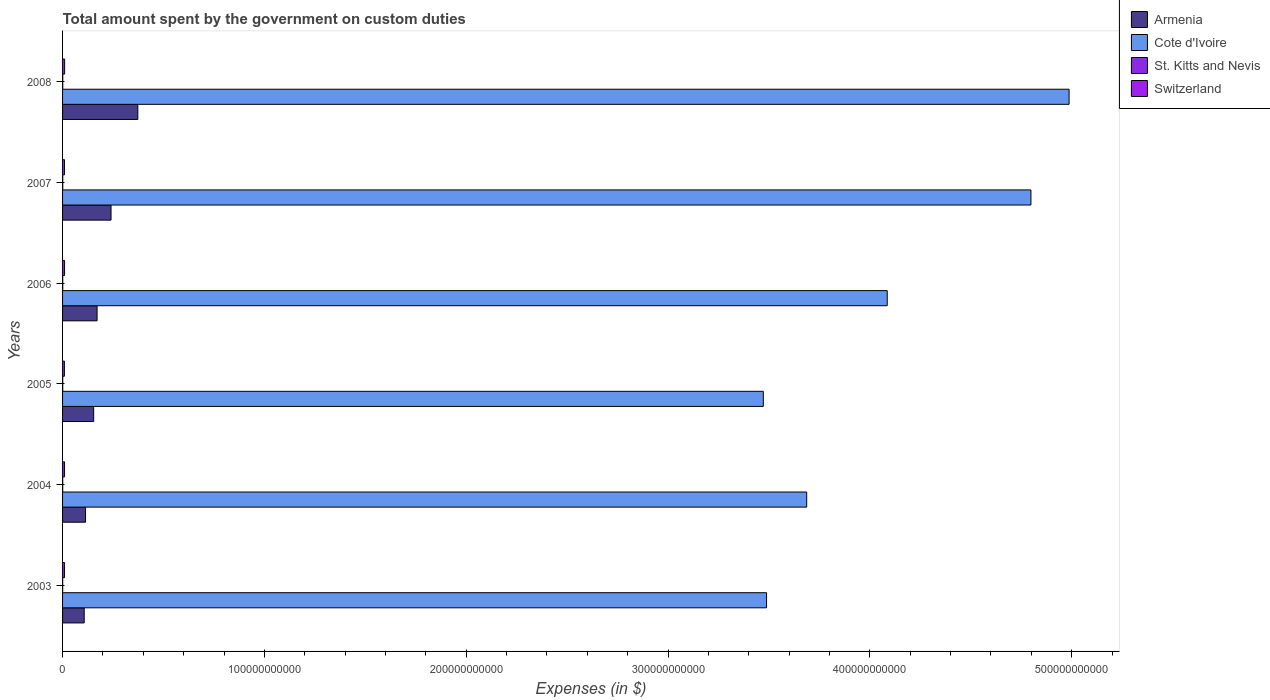How many different coloured bars are there?
Offer a terse response. 4. How many bars are there on the 3rd tick from the top?
Offer a very short reply. 4. How many bars are there on the 6th tick from the bottom?
Your answer should be compact. 4. In how many cases, is the number of bars for a given year not equal to the number of legend labels?
Offer a very short reply. 0. What is the amount spent on custom duties by the government in Cote d'Ivoire in 2006?
Keep it short and to the point. 4.09e+11. Across all years, what is the maximum amount spent on custom duties by the government in Switzerland?
Provide a succinct answer. 1.02e+09. Across all years, what is the minimum amount spent on custom duties by the government in Switzerland?
Your response must be concise. 9.09e+08. What is the total amount spent on custom duties by the government in Armenia in the graph?
Give a very brief answer. 1.16e+11. What is the difference between the amount spent on custom duties by the government in Switzerland in 2003 and that in 2008?
Your answer should be compact. -4.18e+07. What is the difference between the amount spent on custom duties by the government in Cote d'Ivoire in 2006 and the amount spent on custom duties by the government in Switzerland in 2008?
Ensure brevity in your answer.  4.08e+11. What is the average amount spent on custom duties by the government in Armenia per year?
Your answer should be compact. 1.93e+1. In the year 2008, what is the difference between the amount spent on custom duties by the government in Armenia and amount spent on custom duties by the government in Cote d'Ivoire?
Provide a succinct answer. -4.61e+11. In how many years, is the amount spent on custom duties by the government in Cote d'Ivoire greater than 240000000000 $?
Offer a very short reply. 6. What is the ratio of the amount spent on custom duties by the government in Switzerland in 2006 to that in 2007?
Your response must be concise. 1.03. Is the amount spent on custom duties by the government in St. Kitts and Nevis in 2004 less than that in 2007?
Give a very brief answer. Yes. What is the difference between the highest and the second highest amount spent on custom duties by the government in Armenia?
Provide a succinct answer. 1.33e+1. What is the difference between the highest and the lowest amount spent on custom duties by the government in St. Kitts and Nevis?
Ensure brevity in your answer.  3.56e+07. In how many years, is the amount spent on custom duties by the government in St. Kitts and Nevis greater than the average amount spent on custom duties by the government in St. Kitts and Nevis taken over all years?
Offer a terse response. 4. What does the 2nd bar from the top in 2007 represents?
Provide a short and direct response. St. Kitts and Nevis. What does the 3rd bar from the bottom in 2007 represents?
Your answer should be compact. St. Kitts and Nevis. What is the difference between two consecutive major ticks on the X-axis?
Ensure brevity in your answer.  1.00e+11. Where does the legend appear in the graph?
Keep it short and to the point. Top right. What is the title of the graph?
Ensure brevity in your answer.  Total amount spent by the government on custom duties. What is the label or title of the X-axis?
Your answer should be compact. Expenses (in $). What is the Expenses (in $) in Armenia in 2003?
Provide a short and direct response. 1.07e+1. What is the Expenses (in $) in Cote d'Ivoire in 2003?
Offer a very short reply. 3.49e+11. What is the Expenses (in $) of St. Kitts and Nevis in 2003?
Your answer should be very brief. 5.56e+07. What is the Expenses (in $) in Switzerland in 2003?
Give a very brief answer. 9.75e+08. What is the Expenses (in $) of Armenia in 2004?
Offer a terse response. 1.14e+1. What is the Expenses (in $) in Cote d'Ivoire in 2004?
Provide a short and direct response. 3.69e+11. What is the Expenses (in $) in St. Kitts and Nevis in 2004?
Offer a terse response. 6.50e+07. What is the Expenses (in $) of Switzerland in 2004?
Offer a terse response. 9.83e+08. What is the Expenses (in $) of Armenia in 2005?
Provide a short and direct response. 1.54e+1. What is the Expenses (in $) of Cote d'Ivoire in 2005?
Provide a succinct answer. 3.47e+11. What is the Expenses (in $) of St. Kitts and Nevis in 2005?
Offer a very short reply. 8.09e+07. What is the Expenses (in $) in Switzerland in 2005?
Ensure brevity in your answer.  9.09e+08. What is the Expenses (in $) of Armenia in 2006?
Provide a short and direct response. 1.71e+1. What is the Expenses (in $) of Cote d'Ivoire in 2006?
Your answer should be very brief. 4.09e+11. What is the Expenses (in $) of St. Kitts and Nevis in 2006?
Your response must be concise. 8.36e+07. What is the Expenses (in $) in Switzerland in 2006?
Your answer should be very brief. 9.86e+08. What is the Expenses (in $) in Armenia in 2007?
Make the answer very short. 2.40e+1. What is the Expenses (in $) in Cote d'Ivoire in 2007?
Offer a terse response. 4.80e+11. What is the Expenses (in $) of St. Kitts and Nevis in 2007?
Your response must be concise. 8.84e+07. What is the Expenses (in $) of Switzerland in 2007?
Provide a succinct answer. 9.61e+08. What is the Expenses (in $) in Armenia in 2008?
Your answer should be very brief. 3.73e+1. What is the Expenses (in $) of Cote d'Ivoire in 2008?
Offer a terse response. 4.99e+11. What is the Expenses (in $) in St. Kitts and Nevis in 2008?
Provide a short and direct response. 9.12e+07. What is the Expenses (in $) in Switzerland in 2008?
Your answer should be compact. 1.02e+09. Across all years, what is the maximum Expenses (in $) in Armenia?
Give a very brief answer. 3.73e+1. Across all years, what is the maximum Expenses (in $) in Cote d'Ivoire?
Provide a short and direct response. 4.99e+11. Across all years, what is the maximum Expenses (in $) of St. Kitts and Nevis?
Your response must be concise. 9.12e+07. Across all years, what is the maximum Expenses (in $) in Switzerland?
Give a very brief answer. 1.02e+09. Across all years, what is the minimum Expenses (in $) in Armenia?
Your answer should be compact. 1.07e+1. Across all years, what is the minimum Expenses (in $) in Cote d'Ivoire?
Your response must be concise. 3.47e+11. Across all years, what is the minimum Expenses (in $) in St. Kitts and Nevis?
Provide a succinct answer. 5.56e+07. Across all years, what is the minimum Expenses (in $) in Switzerland?
Give a very brief answer. 9.09e+08. What is the total Expenses (in $) in Armenia in the graph?
Your response must be concise. 1.16e+11. What is the total Expenses (in $) of Cote d'Ivoire in the graph?
Make the answer very short. 2.45e+12. What is the total Expenses (in $) of St. Kitts and Nevis in the graph?
Offer a terse response. 4.65e+08. What is the total Expenses (in $) of Switzerland in the graph?
Keep it short and to the point. 5.83e+09. What is the difference between the Expenses (in $) of Armenia in 2003 and that in 2004?
Give a very brief answer. -6.66e+08. What is the difference between the Expenses (in $) in Cote d'Ivoire in 2003 and that in 2004?
Ensure brevity in your answer.  -1.99e+1. What is the difference between the Expenses (in $) of St. Kitts and Nevis in 2003 and that in 2004?
Offer a terse response. -9.40e+06. What is the difference between the Expenses (in $) of Switzerland in 2003 and that in 2004?
Your answer should be compact. -8.05e+06. What is the difference between the Expenses (in $) in Armenia in 2003 and that in 2005?
Keep it short and to the point. -4.69e+09. What is the difference between the Expenses (in $) in Cote d'Ivoire in 2003 and that in 2005?
Your answer should be compact. 1.60e+09. What is the difference between the Expenses (in $) of St. Kitts and Nevis in 2003 and that in 2005?
Ensure brevity in your answer.  -2.53e+07. What is the difference between the Expenses (in $) in Switzerland in 2003 and that in 2005?
Ensure brevity in your answer.  6.64e+07. What is the difference between the Expenses (in $) of Armenia in 2003 and that in 2006?
Offer a terse response. -6.38e+09. What is the difference between the Expenses (in $) in Cote d'Ivoire in 2003 and that in 2006?
Keep it short and to the point. -5.98e+1. What is the difference between the Expenses (in $) in St. Kitts and Nevis in 2003 and that in 2006?
Ensure brevity in your answer.  -2.80e+07. What is the difference between the Expenses (in $) in Switzerland in 2003 and that in 2006?
Your response must be concise. -1.11e+07. What is the difference between the Expenses (in $) of Armenia in 2003 and that in 2007?
Give a very brief answer. -1.33e+1. What is the difference between the Expenses (in $) in Cote d'Ivoire in 2003 and that in 2007?
Your answer should be compact. -1.31e+11. What is the difference between the Expenses (in $) of St. Kitts and Nevis in 2003 and that in 2007?
Provide a short and direct response. -3.28e+07. What is the difference between the Expenses (in $) in Switzerland in 2003 and that in 2007?
Provide a succinct answer. 1.48e+07. What is the difference between the Expenses (in $) of Armenia in 2003 and that in 2008?
Your answer should be very brief. -2.66e+1. What is the difference between the Expenses (in $) in Cote d'Ivoire in 2003 and that in 2008?
Provide a succinct answer. -1.50e+11. What is the difference between the Expenses (in $) in St. Kitts and Nevis in 2003 and that in 2008?
Offer a terse response. -3.56e+07. What is the difference between the Expenses (in $) in Switzerland in 2003 and that in 2008?
Your answer should be very brief. -4.18e+07. What is the difference between the Expenses (in $) of Armenia in 2004 and that in 2005?
Your answer should be very brief. -4.02e+09. What is the difference between the Expenses (in $) in Cote d'Ivoire in 2004 and that in 2005?
Your answer should be compact. 2.15e+1. What is the difference between the Expenses (in $) in St. Kitts and Nevis in 2004 and that in 2005?
Ensure brevity in your answer.  -1.59e+07. What is the difference between the Expenses (in $) in Switzerland in 2004 and that in 2005?
Your answer should be very brief. 7.45e+07. What is the difference between the Expenses (in $) of Armenia in 2004 and that in 2006?
Your answer should be compact. -5.71e+09. What is the difference between the Expenses (in $) in Cote d'Ivoire in 2004 and that in 2006?
Your answer should be very brief. -3.99e+1. What is the difference between the Expenses (in $) of St. Kitts and Nevis in 2004 and that in 2006?
Ensure brevity in your answer.  -1.86e+07. What is the difference between the Expenses (in $) in Switzerland in 2004 and that in 2006?
Your answer should be very brief. -3.08e+06. What is the difference between the Expenses (in $) of Armenia in 2004 and that in 2007?
Your answer should be compact. -1.26e+1. What is the difference between the Expenses (in $) of Cote d'Ivoire in 2004 and that in 2007?
Your answer should be very brief. -1.11e+11. What is the difference between the Expenses (in $) in St. Kitts and Nevis in 2004 and that in 2007?
Your answer should be compact. -2.34e+07. What is the difference between the Expenses (in $) in Switzerland in 2004 and that in 2007?
Provide a short and direct response. 2.28e+07. What is the difference between the Expenses (in $) in Armenia in 2004 and that in 2008?
Offer a terse response. -2.59e+1. What is the difference between the Expenses (in $) of Cote d'Ivoire in 2004 and that in 2008?
Your response must be concise. -1.30e+11. What is the difference between the Expenses (in $) of St. Kitts and Nevis in 2004 and that in 2008?
Keep it short and to the point. -2.62e+07. What is the difference between the Expenses (in $) in Switzerland in 2004 and that in 2008?
Offer a terse response. -3.38e+07. What is the difference between the Expenses (in $) in Armenia in 2005 and that in 2006?
Provide a succinct answer. -1.69e+09. What is the difference between the Expenses (in $) of Cote d'Ivoire in 2005 and that in 2006?
Keep it short and to the point. -6.14e+1. What is the difference between the Expenses (in $) in St. Kitts and Nevis in 2005 and that in 2006?
Give a very brief answer. -2.70e+06. What is the difference between the Expenses (in $) in Switzerland in 2005 and that in 2006?
Provide a short and direct response. -7.76e+07. What is the difference between the Expenses (in $) in Armenia in 2005 and that in 2007?
Your answer should be compact. -8.60e+09. What is the difference between the Expenses (in $) in Cote d'Ivoire in 2005 and that in 2007?
Offer a very short reply. -1.33e+11. What is the difference between the Expenses (in $) of St. Kitts and Nevis in 2005 and that in 2007?
Make the answer very short. -7.50e+06. What is the difference between the Expenses (in $) in Switzerland in 2005 and that in 2007?
Your response must be concise. -5.17e+07. What is the difference between the Expenses (in $) in Armenia in 2005 and that in 2008?
Offer a terse response. -2.19e+1. What is the difference between the Expenses (in $) in Cote d'Ivoire in 2005 and that in 2008?
Keep it short and to the point. -1.52e+11. What is the difference between the Expenses (in $) of St. Kitts and Nevis in 2005 and that in 2008?
Make the answer very short. -1.03e+07. What is the difference between the Expenses (in $) of Switzerland in 2005 and that in 2008?
Your response must be concise. -1.08e+08. What is the difference between the Expenses (in $) in Armenia in 2006 and that in 2007?
Your response must be concise. -6.91e+09. What is the difference between the Expenses (in $) in Cote d'Ivoire in 2006 and that in 2007?
Offer a very short reply. -7.12e+1. What is the difference between the Expenses (in $) in St. Kitts and Nevis in 2006 and that in 2007?
Offer a terse response. -4.80e+06. What is the difference between the Expenses (in $) of Switzerland in 2006 and that in 2007?
Make the answer very short. 2.59e+07. What is the difference between the Expenses (in $) of Armenia in 2006 and that in 2008?
Give a very brief answer. -2.02e+1. What is the difference between the Expenses (in $) of Cote d'Ivoire in 2006 and that in 2008?
Offer a terse response. -9.01e+1. What is the difference between the Expenses (in $) of St. Kitts and Nevis in 2006 and that in 2008?
Provide a short and direct response. -7.60e+06. What is the difference between the Expenses (in $) in Switzerland in 2006 and that in 2008?
Offer a very short reply. -3.07e+07. What is the difference between the Expenses (in $) in Armenia in 2007 and that in 2008?
Your answer should be compact. -1.33e+1. What is the difference between the Expenses (in $) of Cote d'Ivoire in 2007 and that in 2008?
Give a very brief answer. -1.89e+1. What is the difference between the Expenses (in $) in St. Kitts and Nevis in 2007 and that in 2008?
Ensure brevity in your answer.  -2.80e+06. What is the difference between the Expenses (in $) of Switzerland in 2007 and that in 2008?
Make the answer very short. -5.66e+07. What is the difference between the Expenses (in $) in Armenia in 2003 and the Expenses (in $) in Cote d'Ivoire in 2004?
Give a very brief answer. -3.58e+11. What is the difference between the Expenses (in $) in Armenia in 2003 and the Expenses (in $) in St. Kitts and Nevis in 2004?
Offer a very short reply. 1.07e+1. What is the difference between the Expenses (in $) in Armenia in 2003 and the Expenses (in $) in Switzerland in 2004?
Give a very brief answer. 9.74e+09. What is the difference between the Expenses (in $) of Cote d'Ivoire in 2003 and the Expenses (in $) of St. Kitts and Nevis in 2004?
Provide a succinct answer. 3.49e+11. What is the difference between the Expenses (in $) in Cote d'Ivoire in 2003 and the Expenses (in $) in Switzerland in 2004?
Offer a very short reply. 3.48e+11. What is the difference between the Expenses (in $) of St. Kitts and Nevis in 2003 and the Expenses (in $) of Switzerland in 2004?
Give a very brief answer. -9.28e+08. What is the difference between the Expenses (in $) of Armenia in 2003 and the Expenses (in $) of Cote d'Ivoire in 2005?
Give a very brief answer. -3.36e+11. What is the difference between the Expenses (in $) in Armenia in 2003 and the Expenses (in $) in St. Kitts and Nevis in 2005?
Give a very brief answer. 1.06e+1. What is the difference between the Expenses (in $) in Armenia in 2003 and the Expenses (in $) in Switzerland in 2005?
Provide a succinct answer. 9.82e+09. What is the difference between the Expenses (in $) of Cote d'Ivoire in 2003 and the Expenses (in $) of St. Kitts and Nevis in 2005?
Your answer should be compact. 3.49e+11. What is the difference between the Expenses (in $) of Cote d'Ivoire in 2003 and the Expenses (in $) of Switzerland in 2005?
Make the answer very short. 3.48e+11. What is the difference between the Expenses (in $) in St. Kitts and Nevis in 2003 and the Expenses (in $) in Switzerland in 2005?
Ensure brevity in your answer.  -8.53e+08. What is the difference between the Expenses (in $) of Armenia in 2003 and the Expenses (in $) of Cote d'Ivoire in 2006?
Offer a very short reply. -3.98e+11. What is the difference between the Expenses (in $) of Armenia in 2003 and the Expenses (in $) of St. Kitts and Nevis in 2006?
Ensure brevity in your answer.  1.06e+1. What is the difference between the Expenses (in $) of Armenia in 2003 and the Expenses (in $) of Switzerland in 2006?
Offer a very short reply. 9.74e+09. What is the difference between the Expenses (in $) of Cote d'Ivoire in 2003 and the Expenses (in $) of St. Kitts and Nevis in 2006?
Offer a terse response. 3.49e+11. What is the difference between the Expenses (in $) in Cote d'Ivoire in 2003 and the Expenses (in $) in Switzerland in 2006?
Keep it short and to the point. 3.48e+11. What is the difference between the Expenses (in $) in St. Kitts and Nevis in 2003 and the Expenses (in $) in Switzerland in 2006?
Your answer should be compact. -9.31e+08. What is the difference between the Expenses (in $) of Armenia in 2003 and the Expenses (in $) of Cote d'Ivoire in 2007?
Provide a succinct answer. -4.69e+11. What is the difference between the Expenses (in $) in Armenia in 2003 and the Expenses (in $) in St. Kitts and Nevis in 2007?
Give a very brief answer. 1.06e+1. What is the difference between the Expenses (in $) in Armenia in 2003 and the Expenses (in $) in Switzerland in 2007?
Ensure brevity in your answer.  9.76e+09. What is the difference between the Expenses (in $) in Cote d'Ivoire in 2003 and the Expenses (in $) in St. Kitts and Nevis in 2007?
Your answer should be compact. 3.49e+11. What is the difference between the Expenses (in $) in Cote d'Ivoire in 2003 and the Expenses (in $) in Switzerland in 2007?
Provide a succinct answer. 3.48e+11. What is the difference between the Expenses (in $) of St. Kitts and Nevis in 2003 and the Expenses (in $) of Switzerland in 2007?
Ensure brevity in your answer.  -9.05e+08. What is the difference between the Expenses (in $) in Armenia in 2003 and the Expenses (in $) in Cote d'Ivoire in 2008?
Offer a terse response. -4.88e+11. What is the difference between the Expenses (in $) of Armenia in 2003 and the Expenses (in $) of St. Kitts and Nevis in 2008?
Your answer should be very brief. 1.06e+1. What is the difference between the Expenses (in $) of Armenia in 2003 and the Expenses (in $) of Switzerland in 2008?
Offer a very short reply. 9.71e+09. What is the difference between the Expenses (in $) in Cote d'Ivoire in 2003 and the Expenses (in $) in St. Kitts and Nevis in 2008?
Your response must be concise. 3.49e+11. What is the difference between the Expenses (in $) of Cote d'Ivoire in 2003 and the Expenses (in $) of Switzerland in 2008?
Your response must be concise. 3.48e+11. What is the difference between the Expenses (in $) of St. Kitts and Nevis in 2003 and the Expenses (in $) of Switzerland in 2008?
Give a very brief answer. -9.61e+08. What is the difference between the Expenses (in $) in Armenia in 2004 and the Expenses (in $) in Cote d'Ivoire in 2005?
Provide a short and direct response. -3.36e+11. What is the difference between the Expenses (in $) in Armenia in 2004 and the Expenses (in $) in St. Kitts and Nevis in 2005?
Your answer should be very brief. 1.13e+1. What is the difference between the Expenses (in $) in Armenia in 2004 and the Expenses (in $) in Switzerland in 2005?
Keep it short and to the point. 1.05e+1. What is the difference between the Expenses (in $) in Cote d'Ivoire in 2004 and the Expenses (in $) in St. Kitts and Nevis in 2005?
Your response must be concise. 3.69e+11. What is the difference between the Expenses (in $) of Cote d'Ivoire in 2004 and the Expenses (in $) of Switzerland in 2005?
Your answer should be compact. 3.68e+11. What is the difference between the Expenses (in $) in St. Kitts and Nevis in 2004 and the Expenses (in $) in Switzerland in 2005?
Your response must be concise. -8.44e+08. What is the difference between the Expenses (in $) of Armenia in 2004 and the Expenses (in $) of Cote d'Ivoire in 2006?
Provide a short and direct response. -3.97e+11. What is the difference between the Expenses (in $) in Armenia in 2004 and the Expenses (in $) in St. Kitts and Nevis in 2006?
Your answer should be compact. 1.13e+1. What is the difference between the Expenses (in $) of Armenia in 2004 and the Expenses (in $) of Switzerland in 2006?
Keep it short and to the point. 1.04e+1. What is the difference between the Expenses (in $) in Cote d'Ivoire in 2004 and the Expenses (in $) in St. Kitts and Nevis in 2006?
Make the answer very short. 3.69e+11. What is the difference between the Expenses (in $) of Cote d'Ivoire in 2004 and the Expenses (in $) of Switzerland in 2006?
Provide a short and direct response. 3.68e+11. What is the difference between the Expenses (in $) in St. Kitts and Nevis in 2004 and the Expenses (in $) in Switzerland in 2006?
Make the answer very short. -9.21e+08. What is the difference between the Expenses (in $) in Armenia in 2004 and the Expenses (in $) in Cote d'Ivoire in 2007?
Provide a short and direct response. -4.68e+11. What is the difference between the Expenses (in $) of Armenia in 2004 and the Expenses (in $) of St. Kitts and Nevis in 2007?
Provide a succinct answer. 1.13e+1. What is the difference between the Expenses (in $) of Armenia in 2004 and the Expenses (in $) of Switzerland in 2007?
Your answer should be compact. 1.04e+1. What is the difference between the Expenses (in $) in Cote d'Ivoire in 2004 and the Expenses (in $) in St. Kitts and Nevis in 2007?
Your answer should be compact. 3.69e+11. What is the difference between the Expenses (in $) of Cote d'Ivoire in 2004 and the Expenses (in $) of Switzerland in 2007?
Ensure brevity in your answer.  3.68e+11. What is the difference between the Expenses (in $) of St. Kitts and Nevis in 2004 and the Expenses (in $) of Switzerland in 2007?
Keep it short and to the point. -8.96e+08. What is the difference between the Expenses (in $) in Armenia in 2004 and the Expenses (in $) in Cote d'Ivoire in 2008?
Your answer should be compact. -4.87e+11. What is the difference between the Expenses (in $) in Armenia in 2004 and the Expenses (in $) in St. Kitts and Nevis in 2008?
Your answer should be very brief. 1.13e+1. What is the difference between the Expenses (in $) of Armenia in 2004 and the Expenses (in $) of Switzerland in 2008?
Keep it short and to the point. 1.04e+1. What is the difference between the Expenses (in $) of Cote d'Ivoire in 2004 and the Expenses (in $) of St. Kitts and Nevis in 2008?
Provide a succinct answer. 3.69e+11. What is the difference between the Expenses (in $) in Cote d'Ivoire in 2004 and the Expenses (in $) in Switzerland in 2008?
Offer a very short reply. 3.68e+11. What is the difference between the Expenses (in $) in St. Kitts and Nevis in 2004 and the Expenses (in $) in Switzerland in 2008?
Ensure brevity in your answer.  -9.52e+08. What is the difference between the Expenses (in $) in Armenia in 2005 and the Expenses (in $) in Cote d'Ivoire in 2006?
Your answer should be very brief. -3.93e+11. What is the difference between the Expenses (in $) of Armenia in 2005 and the Expenses (in $) of St. Kitts and Nevis in 2006?
Keep it short and to the point. 1.53e+1. What is the difference between the Expenses (in $) in Armenia in 2005 and the Expenses (in $) in Switzerland in 2006?
Offer a very short reply. 1.44e+1. What is the difference between the Expenses (in $) in Cote d'Ivoire in 2005 and the Expenses (in $) in St. Kitts and Nevis in 2006?
Provide a succinct answer. 3.47e+11. What is the difference between the Expenses (in $) in Cote d'Ivoire in 2005 and the Expenses (in $) in Switzerland in 2006?
Make the answer very short. 3.46e+11. What is the difference between the Expenses (in $) in St. Kitts and Nevis in 2005 and the Expenses (in $) in Switzerland in 2006?
Provide a succinct answer. -9.06e+08. What is the difference between the Expenses (in $) in Armenia in 2005 and the Expenses (in $) in Cote d'Ivoire in 2007?
Your answer should be very brief. -4.64e+11. What is the difference between the Expenses (in $) in Armenia in 2005 and the Expenses (in $) in St. Kitts and Nevis in 2007?
Keep it short and to the point. 1.53e+1. What is the difference between the Expenses (in $) in Armenia in 2005 and the Expenses (in $) in Switzerland in 2007?
Offer a very short reply. 1.44e+1. What is the difference between the Expenses (in $) of Cote d'Ivoire in 2005 and the Expenses (in $) of St. Kitts and Nevis in 2007?
Give a very brief answer. 3.47e+11. What is the difference between the Expenses (in $) of Cote d'Ivoire in 2005 and the Expenses (in $) of Switzerland in 2007?
Offer a terse response. 3.46e+11. What is the difference between the Expenses (in $) in St. Kitts and Nevis in 2005 and the Expenses (in $) in Switzerland in 2007?
Ensure brevity in your answer.  -8.80e+08. What is the difference between the Expenses (in $) in Armenia in 2005 and the Expenses (in $) in Cote d'Ivoire in 2008?
Offer a very short reply. -4.83e+11. What is the difference between the Expenses (in $) of Armenia in 2005 and the Expenses (in $) of St. Kitts and Nevis in 2008?
Your response must be concise. 1.53e+1. What is the difference between the Expenses (in $) in Armenia in 2005 and the Expenses (in $) in Switzerland in 2008?
Your response must be concise. 1.44e+1. What is the difference between the Expenses (in $) of Cote d'Ivoire in 2005 and the Expenses (in $) of St. Kitts and Nevis in 2008?
Make the answer very short. 3.47e+11. What is the difference between the Expenses (in $) of Cote d'Ivoire in 2005 and the Expenses (in $) of Switzerland in 2008?
Your answer should be compact. 3.46e+11. What is the difference between the Expenses (in $) in St. Kitts and Nevis in 2005 and the Expenses (in $) in Switzerland in 2008?
Make the answer very short. -9.36e+08. What is the difference between the Expenses (in $) in Armenia in 2006 and the Expenses (in $) in Cote d'Ivoire in 2007?
Keep it short and to the point. -4.63e+11. What is the difference between the Expenses (in $) of Armenia in 2006 and the Expenses (in $) of St. Kitts and Nevis in 2007?
Provide a succinct answer. 1.70e+1. What is the difference between the Expenses (in $) in Armenia in 2006 and the Expenses (in $) in Switzerland in 2007?
Provide a short and direct response. 1.61e+1. What is the difference between the Expenses (in $) of Cote d'Ivoire in 2006 and the Expenses (in $) of St. Kitts and Nevis in 2007?
Your response must be concise. 4.09e+11. What is the difference between the Expenses (in $) of Cote d'Ivoire in 2006 and the Expenses (in $) of Switzerland in 2007?
Offer a terse response. 4.08e+11. What is the difference between the Expenses (in $) in St. Kitts and Nevis in 2006 and the Expenses (in $) in Switzerland in 2007?
Provide a succinct answer. -8.77e+08. What is the difference between the Expenses (in $) in Armenia in 2006 and the Expenses (in $) in Cote d'Ivoire in 2008?
Ensure brevity in your answer.  -4.82e+11. What is the difference between the Expenses (in $) of Armenia in 2006 and the Expenses (in $) of St. Kitts and Nevis in 2008?
Make the answer very short. 1.70e+1. What is the difference between the Expenses (in $) of Armenia in 2006 and the Expenses (in $) of Switzerland in 2008?
Your answer should be compact. 1.61e+1. What is the difference between the Expenses (in $) in Cote d'Ivoire in 2006 and the Expenses (in $) in St. Kitts and Nevis in 2008?
Your answer should be very brief. 4.09e+11. What is the difference between the Expenses (in $) of Cote d'Ivoire in 2006 and the Expenses (in $) of Switzerland in 2008?
Offer a very short reply. 4.08e+11. What is the difference between the Expenses (in $) of St. Kitts and Nevis in 2006 and the Expenses (in $) of Switzerland in 2008?
Offer a terse response. -9.33e+08. What is the difference between the Expenses (in $) of Armenia in 2007 and the Expenses (in $) of Cote d'Ivoire in 2008?
Offer a very short reply. -4.75e+11. What is the difference between the Expenses (in $) of Armenia in 2007 and the Expenses (in $) of St. Kitts and Nevis in 2008?
Your response must be concise. 2.39e+1. What is the difference between the Expenses (in $) in Armenia in 2007 and the Expenses (in $) in Switzerland in 2008?
Provide a succinct answer. 2.30e+1. What is the difference between the Expenses (in $) in Cote d'Ivoire in 2007 and the Expenses (in $) in St. Kitts and Nevis in 2008?
Your response must be concise. 4.80e+11. What is the difference between the Expenses (in $) of Cote d'Ivoire in 2007 and the Expenses (in $) of Switzerland in 2008?
Provide a succinct answer. 4.79e+11. What is the difference between the Expenses (in $) of St. Kitts and Nevis in 2007 and the Expenses (in $) of Switzerland in 2008?
Provide a short and direct response. -9.29e+08. What is the average Expenses (in $) in Armenia per year?
Your answer should be compact. 1.93e+1. What is the average Expenses (in $) of Cote d'Ivoire per year?
Make the answer very short. 4.09e+11. What is the average Expenses (in $) of St. Kitts and Nevis per year?
Ensure brevity in your answer.  7.74e+07. What is the average Expenses (in $) in Switzerland per year?
Offer a very short reply. 9.72e+08. In the year 2003, what is the difference between the Expenses (in $) of Armenia and Expenses (in $) of Cote d'Ivoire?
Your answer should be compact. -3.38e+11. In the year 2003, what is the difference between the Expenses (in $) in Armenia and Expenses (in $) in St. Kitts and Nevis?
Your response must be concise. 1.07e+1. In the year 2003, what is the difference between the Expenses (in $) of Armenia and Expenses (in $) of Switzerland?
Offer a very short reply. 9.75e+09. In the year 2003, what is the difference between the Expenses (in $) in Cote d'Ivoire and Expenses (in $) in St. Kitts and Nevis?
Give a very brief answer. 3.49e+11. In the year 2003, what is the difference between the Expenses (in $) of Cote d'Ivoire and Expenses (in $) of Switzerland?
Provide a succinct answer. 3.48e+11. In the year 2003, what is the difference between the Expenses (in $) of St. Kitts and Nevis and Expenses (in $) of Switzerland?
Your answer should be very brief. -9.20e+08. In the year 2004, what is the difference between the Expenses (in $) in Armenia and Expenses (in $) in Cote d'Ivoire?
Provide a short and direct response. -3.57e+11. In the year 2004, what is the difference between the Expenses (in $) in Armenia and Expenses (in $) in St. Kitts and Nevis?
Your response must be concise. 1.13e+1. In the year 2004, what is the difference between the Expenses (in $) in Armenia and Expenses (in $) in Switzerland?
Provide a succinct answer. 1.04e+1. In the year 2004, what is the difference between the Expenses (in $) in Cote d'Ivoire and Expenses (in $) in St. Kitts and Nevis?
Give a very brief answer. 3.69e+11. In the year 2004, what is the difference between the Expenses (in $) of Cote d'Ivoire and Expenses (in $) of Switzerland?
Provide a short and direct response. 3.68e+11. In the year 2004, what is the difference between the Expenses (in $) in St. Kitts and Nevis and Expenses (in $) in Switzerland?
Provide a short and direct response. -9.18e+08. In the year 2005, what is the difference between the Expenses (in $) of Armenia and Expenses (in $) of Cote d'Ivoire?
Ensure brevity in your answer.  -3.32e+11. In the year 2005, what is the difference between the Expenses (in $) of Armenia and Expenses (in $) of St. Kitts and Nevis?
Your answer should be very brief. 1.53e+1. In the year 2005, what is the difference between the Expenses (in $) of Armenia and Expenses (in $) of Switzerland?
Your answer should be very brief. 1.45e+1. In the year 2005, what is the difference between the Expenses (in $) in Cote d'Ivoire and Expenses (in $) in St. Kitts and Nevis?
Provide a short and direct response. 3.47e+11. In the year 2005, what is the difference between the Expenses (in $) in Cote d'Ivoire and Expenses (in $) in Switzerland?
Provide a short and direct response. 3.46e+11. In the year 2005, what is the difference between the Expenses (in $) in St. Kitts and Nevis and Expenses (in $) in Switzerland?
Ensure brevity in your answer.  -8.28e+08. In the year 2006, what is the difference between the Expenses (in $) of Armenia and Expenses (in $) of Cote d'Ivoire?
Give a very brief answer. -3.91e+11. In the year 2006, what is the difference between the Expenses (in $) in Armenia and Expenses (in $) in St. Kitts and Nevis?
Your response must be concise. 1.70e+1. In the year 2006, what is the difference between the Expenses (in $) in Armenia and Expenses (in $) in Switzerland?
Ensure brevity in your answer.  1.61e+1. In the year 2006, what is the difference between the Expenses (in $) in Cote d'Ivoire and Expenses (in $) in St. Kitts and Nevis?
Ensure brevity in your answer.  4.09e+11. In the year 2006, what is the difference between the Expenses (in $) in Cote d'Ivoire and Expenses (in $) in Switzerland?
Your answer should be compact. 4.08e+11. In the year 2006, what is the difference between the Expenses (in $) of St. Kitts and Nevis and Expenses (in $) of Switzerland?
Provide a succinct answer. -9.03e+08. In the year 2007, what is the difference between the Expenses (in $) in Armenia and Expenses (in $) in Cote d'Ivoire?
Provide a succinct answer. -4.56e+11. In the year 2007, what is the difference between the Expenses (in $) of Armenia and Expenses (in $) of St. Kitts and Nevis?
Ensure brevity in your answer.  2.39e+1. In the year 2007, what is the difference between the Expenses (in $) in Armenia and Expenses (in $) in Switzerland?
Offer a terse response. 2.30e+1. In the year 2007, what is the difference between the Expenses (in $) of Cote d'Ivoire and Expenses (in $) of St. Kitts and Nevis?
Make the answer very short. 4.80e+11. In the year 2007, what is the difference between the Expenses (in $) of Cote d'Ivoire and Expenses (in $) of Switzerland?
Provide a short and direct response. 4.79e+11. In the year 2007, what is the difference between the Expenses (in $) of St. Kitts and Nevis and Expenses (in $) of Switzerland?
Ensure brevity in your answer.  -8.72e+08. In the year 2008, what is the difference between the Expenses (in $) in Armenia and Expenses (in $) in Cote d'Ivoire?
Offer a terse response. -4.61e+11. In the year 2008, what is the difference between the Expenses (in $) of Armenia and Expenses (in $) of St. Kitts and Nevis?
Make the answer very short. 3.72e+1. In the year 2008, what is the difference between the Expenses (in $) of Armenia and Expenses (in $) of Switzerland?
Make the answer very short. 3.63e+1. In the year 2008, what is the difference between the Expenses (in $) of Cote d'Ivoire and Expenses (in $) of St. Kitts and Nevis?
Your answer should be compact. 4.99e+11. In the year 2008, what is the difference between the Expenses (in $) of Cote d'Ivoire and Expenses (in $) of Switzerland?
Give a very brief answer. 4.98e+11. In the year 2008, what is the difference between the Expenses (in $) in St. Kitts and Nevis and Expenses (in $) in Switzerland?
Ensure brevity in your answer.  -9.26e+08. What is the ratio of the Expenses (in $) in Armenia in 2003 to that in 2004?
Your answer should be very brief. 0.94. What is the ratio of the Expenses (in $) of Cote d'Ivoire in 2003 to that in 2004?
Your answer should be compact. 0.95. What is the ratio of the Expenses (in $) in St. Kitts and Nevis in 2003 to that in 2004?
Your answer should be very brief. 0.86. What is the ratio of the Expenses (in $) of Armenia in 2003 to that in 2005?
Your response must be concise. 0.7. What is the ratio of the Expenses (in $) of Cote d'Ivoire in 2003 to that in 2005?
Provide a short and direct response. 1. What is the ratio of the Expenses (in $) in St. Kitts and Nevis in 2003 to that in 2005?
Ensure brevity in your answer.  0.69. What is the ratio of the Expenses (in $) in Switzerland in 2003 to that in 2005?
Provide a short and direct response. 1.07. What is the ratio of the Expenses (in $) in Armenia in 2003 to that in 2006?
Your answer should be very brief. 0.63. What is the ratio of the Expenses (in $) in Cote d'Ivoire in 2003 to that in 2006?
Offer a terse response. 0.85. What is the ratio of the Expenses (in $) of St. Kitts and Nevis in 2003 to that in 2006?
Offer a very short reply. 0.67. What is the ratio of the Expenses (in $) of Switzerland in 2003 to that in 2006?
Give a very brief answer. 0.99. What is the ratio of the Expenses (in $) in Armenia in 2003 to that in 2007?
Offer a terse response. 0.45. What is the ratio of the Expenses (in $) of Cote d'Ivoire in 2003 to that in 2007?
Make the answer very short. 0.73. What is the ratio of the Expenses (in $) of St. Kitts and Nevis in 2003 to that in 2007?
Provide a short and direct response. 0.63. What is the ratio of the Expenses (in $) of Switzerland in 2003 to that in 2007?
Provide a succinct answer. 1.02. What is the ratio of the Expenses (in $) in Armenia in 2003 to that in 2008?
Your response must be concise. 0.29. What is the ratio of the Expenses (in $) of Cote d'Ivoire in 2003 to that in 2008?
Ensure brevity in your answer.  0.7. What is the ratio of the Expenses (in $) in St. Kitts and Nevis in 2003 to that in 2008?
Offer a terse response. 0.61. What is the ratio of the Expenses (in $) of Switzerland in 2003 to that in 2008?
Your response must be concise. 0.96. What is the ratio of the Expenses (in $) of Armenia in 2004 to that in 2005?
Ensure brevity in your answer.  0.74. What is the ratio of the Expenses (in $) in Cote d'Ivoire in 2004 to that in 2005?
Your response must be concise. 1.06. What is the ratio of the Expenses (in $) in St. Kitts and Nevis in 2004 to that in 2005?
Your answer should be very brief. 0.8. What is the ratio of the Expenses (in $) of Switzerland in 2004 to that in 2005?
Your response must be concise. 1.08. What is the ratio of the Expenses (in $) of Armenia in 2004 to that in 2006?
Your answer should be very brief. 0.67. What is the ratio of the Expenses (in $) of Cote d'Ivoire in 2004 to that in 2006?
Provide a short and direct response. 0.9. What is the ratio of the Expenses (in $) of St. Kitts and Nevis in 2004 to that in 2006?
Your response must be concise. 0.78. What is the ratio of the Expenses (in $) of Switzerland in 2004 to that in 2006?
Provide a succinct answer. 1. What is the ratio of the Expenses (in $) in Armenia in 2004 to that in 2007?
Offer a terse response. 0.47. What is the ratio of the Expenses (in $) in Cote d'Ivoire in 2004 to that in 2007?
Your response must be concise. 0.77. What is the ratio of the Expenses (in $) in St. Kitts and Nevis in 2004 to that in 2007?
Your response must be concise. 0.74. What is the ratio of the Expenses (in $) in Switzerland in 2004 to that in 2007?
Ensure brevity in your answer.  1.02. What is the ratio of the Expenses (in $) of Armenia in 2004 to that in 2008?
Make the answer very short. 0.31. What is the ratio of the Expenses (in $) of Cote d'Ivoire in 2004 to that in 2008?
Provide a succinct answer. 0.74. What is the ratio of the Expenses (in $) in St. Kitts and Nevis in 2004 to that in 2008?
Give a very brief answer. 0.71. What is the ratio of the Expenses (in $) of Switzerland in 2004 to that in 2008?
Give a very brief answer. 0.97. What is the ratio of the Expenses (in $) in Armenia in 2005 to that in 2006?
Make the answer very short. 0.9. What is the ratio of the Expenses (in $) of Cote d'Ivoire in 2005 to that in 2006?
Offer a very short reply. 0.85. What is the ratio of the Expenses (in $) of St. Kitts and Nevis in 2005 to that in 2006?
Keep it short and to the point. 0.97. What is the ratio of the Expenses (in $) in Switzerland in 2005 to that in 2006?
Keep it short and to the point. 0.92. What is the ratio of the Expenses (in $) of Armenia in 2005 to that in 2007?
Offer a terse response. 0.64. What is the ratio of the Expenses (in $) of Cote d'Ivoire in 2005 to that in 2007?
Make the answer very short. 0.72. What is the ratio of the Expenses (in $) of St. Kitts and Nevis in 2005 to that in 2007?
Provide a short and direct response. 0.92. What is the ratio of the Expenses (in $) of Switzerland in 2005 to that in 2007?
Give a very brief answer. 0.95. What is the ratio of the Expenses (in $) of Armenia in 2005 to that in 2008?
Ensure brevity in your answer.  0.41. What is the ratio of the Expenses (in $) of Cote d'Ivoire in 2005 to that in 2008?
Offer a very short reply. 0.7. What is the ratio of the Expenses (in $) of St. Kitts and Nevis in 2005 to that in 2008?
Provide a short and direct response. 0.89. What is the ratio of the Expenses (in $) of Switzerland in 2005 to that in 2008?
Provide a succinct answer. 0.89. What is the ratio of the Expenses (in $) in Armenia in 2006 to that in 2007?
Provide a short and direct response. 0.71. What is the ratio of the Expenses (in $) of Cote d'Ivoire in 2006 to that in 2007?
Provide a succinct answer. 0.85. What is the ratio of the Expenses (in $) in St. Kitts and Nevis in 2006 to that in 2007?
Your answer should be compact. 0.95. What is the ratio of the Expenses (in $) in Switzerland in 2006 to that in 2007?
Your response must be concise. 1.03. What is the ratio of the Expenses (in $) of Armenia in 2006 to that in 2008?
Provide a succinct answer. 0.46. What is the ratio of the Expenses (in $) in Cote d'Ivoire in 2006 to that in 2008?
Offer a terse response. 0.82. What is the ratio of the Expenses (in $) in St. Kitts and Nevis in 2006 to that in 2008?
Keep it short and to the point. 0.92. What is the ratio of the Expenses (in $) in Switzerland in 2006 to that in 2008?
Ensure brevity in your answer.  0.97. What is the ratio of the Expenses (in $) of Armenia in 2007 to that in 2008?
Offer a very short reply. 0.64. What is the ratio of the Expenses (in $) of Cote d'Ivoire in 2007 to that in 2008?
Give a very brief answer. 0.96. What is the ratio of the Expenses (in $) in St. Kitts and Nevis in 2007 to that in 2008?
Your answer should be compact. 0.97. What is the difference between the highest and the second highest Expenses (in $) in Armenia?
Give a very brief answer. 1.33e+1. What is the difference between the highest and the second highest Expenses (in $) in Cote d'Ivoire?
Provide a succinct answer. 1.89e+1. What is the difference between the highest and the second highest Expenses (in $) of St. Kitts and Nevis?
Provide a succinct answer. 2.80e+06. What is the difference between the highest and the second highest Expenses (in $) of Switzerland?
Give a very brief answer. 3.07e+07. What is the difference between the highest and the lowest Expenses (in $) in Armenia?
Your answer should be very brief. 2.66e+1. What is the difference between the highest and the lowest Expenses (in $) in Cote d'Ivoire?
Provide a short and direct response. 1.52e+11. What is the difference between the highest and the lowest Expenses (in $) in St. Kitts and Nevis?
Ensure brevity in your answer.  3.56e+07. What is the difference between the highest and the lowest Expenses (in $) in Switzerland?
Provide a short and direct response. 1.08e+08. 